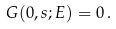Convert formula to latex. <formula><loc_0><loc_0><loc_500><loc_500>G ( 0 , s ; E ) = 0 \, .</formula> 